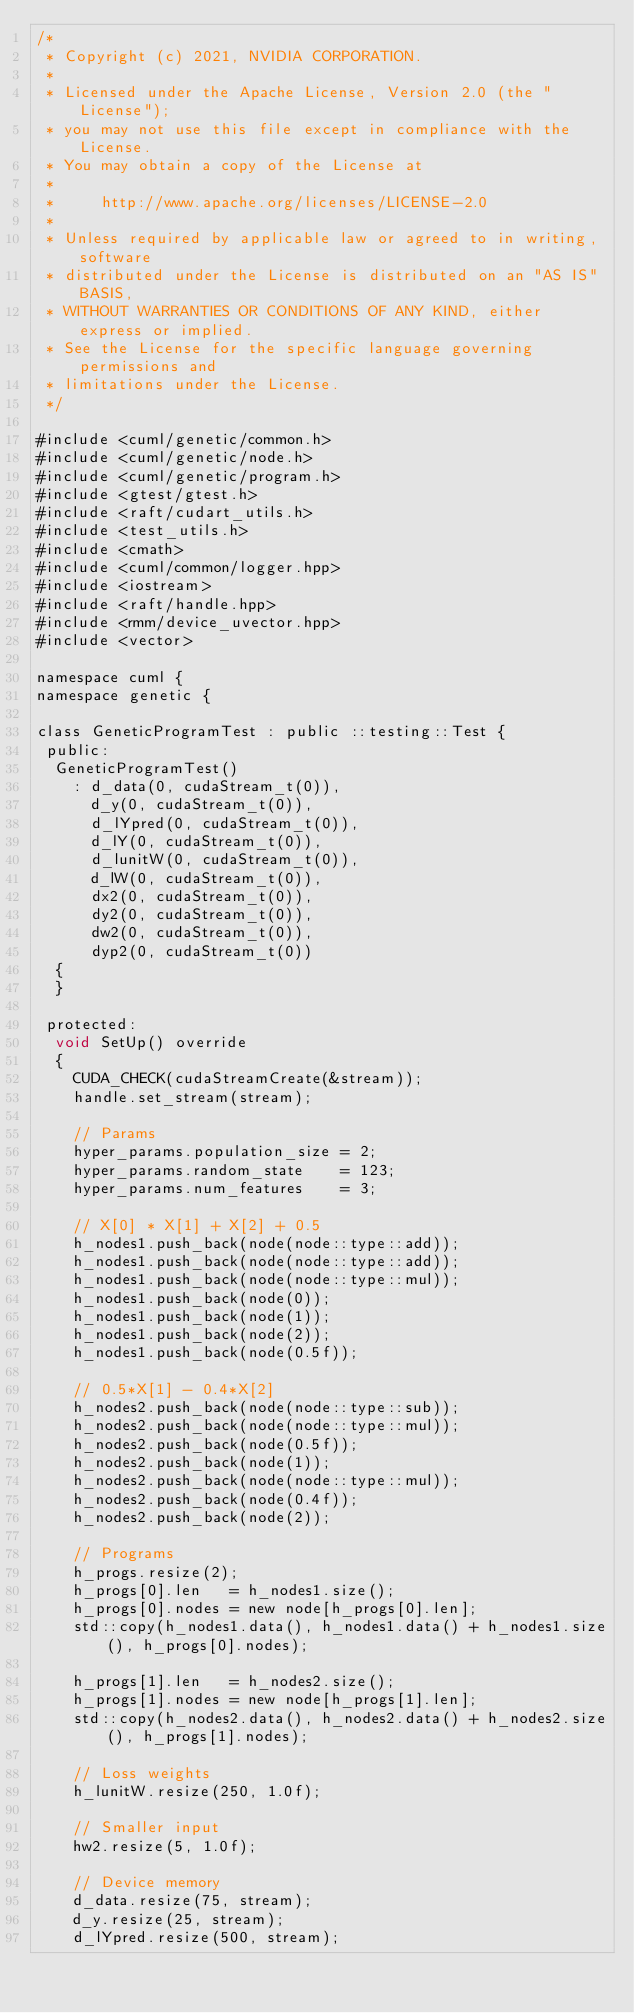Convert code to text. <code><loc_0><loc_0><loc_500><loc_500><_Cuda_>/*
 * Copyright (c) 2021, NVIDIA CORPORATION.
 *
 * Licensed under the Apache License, Version 2.0 (the "License");
 * you may not use this file except in compliance with the License.
 * You may obtain a copy of the License at
 *
 *     http://www.apache.org/licenses/LICENSE-2.0
 *
 * Unless required by applicable law or agreed to in writing, software
 * distributed under the License is distributed on an "AS IS" BASIS,
 * WITHOUT WARRANTIES OR CONDITIONS OF ANY KIND, either express or implied.
 * See the License for the specific language governing permissions and
 * limitations under the License.
 */

#include <cuml/genetic/common.h>
#include <cuml/genetic/node.h>
#include <cuml/genetic/program.h>
#include <gtest/gtest.h>
#include <raft/cudart_utils.h>
#include <test_utils.h>
#include <cmath>
#include <cuml/common/logger.hpp>
#include <iostream>
#include <raft/handle.hpp>
#include <rmm/device_uvector.hpp>
#include <vector>

namespace cuml {
namespace genetic {

class GeneticProgramTest : public ::testing::Test {
 public:
  GeneticProgramTest()
    : d_data(0, cudaStream_t(0)),
      d_y(0, cudaStream_t(0)),
      d_lYpred(0, cudaStream_t(0)),
      d_lY(0, cudaStream_t(0)),
      d_lunitW(0, cudaStream_t(0)),
      d_lW(0, cudaStream_t(0)),
      dx2(0, cudaStream_t(0)),
      dy2(0, cudaStream_t(0)),
      dw2(0, cudaStream_t(0)),
      dyp2(0, cudaStream_t(0))
  {
  }

 protected:
  void SetUp() override
  {
    CUDA_CHECK(cudaStreamCreate(&stream));
    handle.set_stream(stream);

    // Params
    hyper_params.population_size = 2;
    hyper_params.random_state    = 123;
    hyper_params.num_features    = 3;

    // X[0] * X[1] + X[2] + 0.5
    h_nodes1.push_back(node(node::type::add));
    h_nodes1.push_back(node(node::type::add));
    h_nodes1.push_back(node(node::type::mul));
    h_nodes1.push_back(node(0));
    h_nodes1.push_back(node(1));
    h_nodes1.push_back(node(2));
    h_nodes1.push_back(node(0.5f));

    // 0.5*X[1] - 0.4*X[2]
    h_nodes2.push_back(node(node::type::sub));
    h_nodes2.push_back(node(node::type::mul));
    h_nodes2.push_back(node(0.5f));
    h_nodes2.push_back(node(1));
    h_nodes2.push_back(node(node::type::mul));
    h_nodes2.push_back(node(0.4f));
    h_nodes2.push_back(node(2));

    // Programs
    h_progs.resize(2);
    h_progs[0].len   = h_nodes1.size();
    h_progs[0].nodes = new node[h_progs[0].len];
    std::copy(h_nodes1.data(), h_nodes1.data() + h_nodes1.size(), h_progs[0].nodes);

    h_progs[1].len   = h_nodes2.size();
    h_progs[1].nodes = new node[h_progs[1].len];
    std::copy(h_nodes2.data(), h_nodes2.data() + h_nodes2.size(), h_progs[1].nodes);

    // Loss weights
    h_lunitW.resize(250, 1.0f);

    // Smaller input
    hw2.resize(5, 1.0f);

    // Device memory
    d_data.resize(75, stream);
    d_y.resize(25, stream);
    d_lYpred.resize(500, stream);</code> 